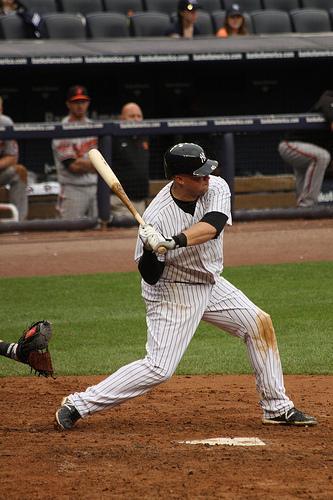How many players are there?
Give a very brief answer. 6. 